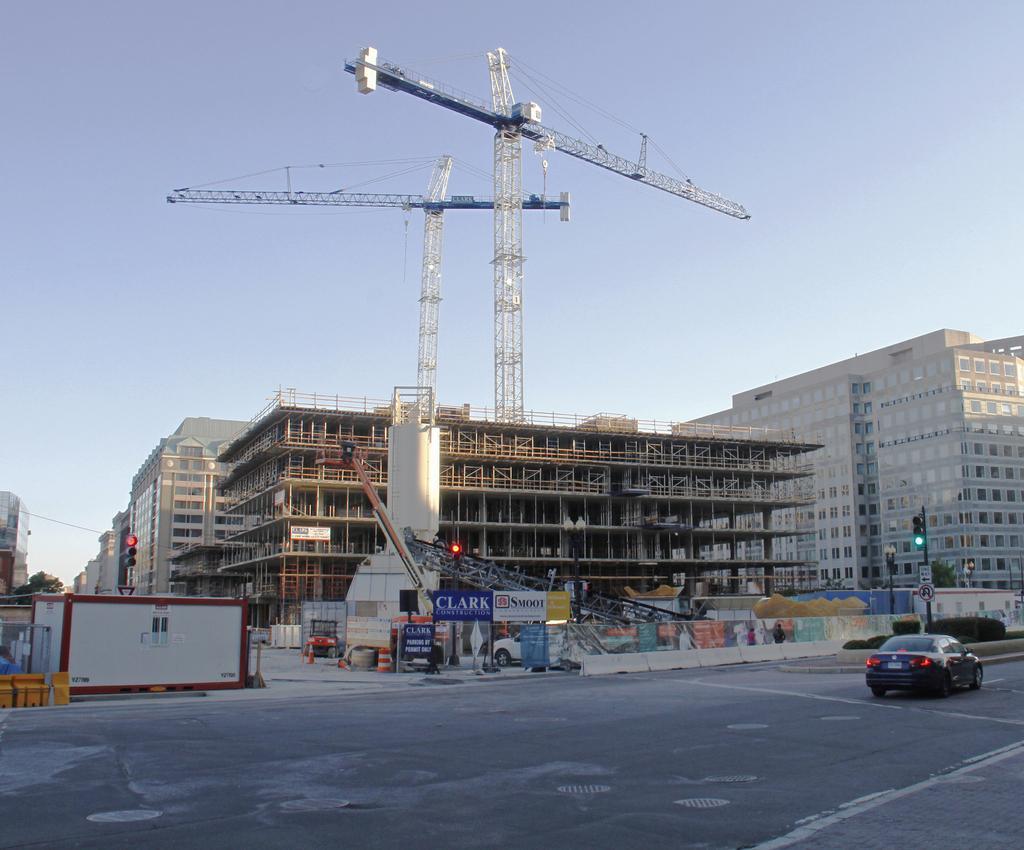Could you give a brief overview of what you see in this image? In this image I can see the vehicle on the road. To the side I can see many boards, crane, signal poles and the buildings. In the background I can also see few more cranes and the sky. 